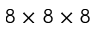<formula> <loc_0><loc_0><loc_500><loc_500>8 \times 8 \times 8</formula> 